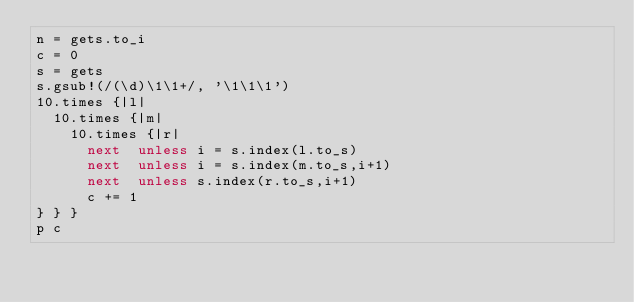Convert code to text. <code><loc_0><loc_0><loc_500><loc_500><_Ruby_>n = gets.to_i
c = 0
s = gets
s.gsub!(/(\d)\1\1+/, '\1\1\1')
10.times {|l|
  10.times {|m|
    10.times {|r|
      next  unless i = s.index(l.to_s)
      next  unless i = s.index(m.to_s,i+1)
      next  unless s.index(r.to_s,i+1)
      c += 1
} } }
p c</code> 